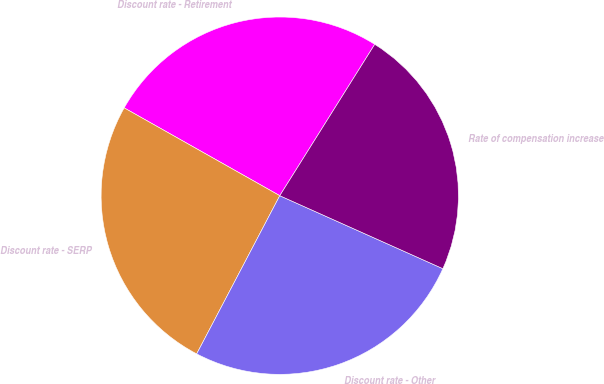Convert chart. <chart><loc_0><loc_0><loc_500><loc_500><pie_chart><fcel>Discount rate - Retirement<fcel>Discount rate - SERP<fcel>Discount rate - Other<fcel>Rate of compensation increase<nl><fcel>25.74%<fcel>25.48%<fcel>26.0%<fcel>22.78%<nl></chart> 